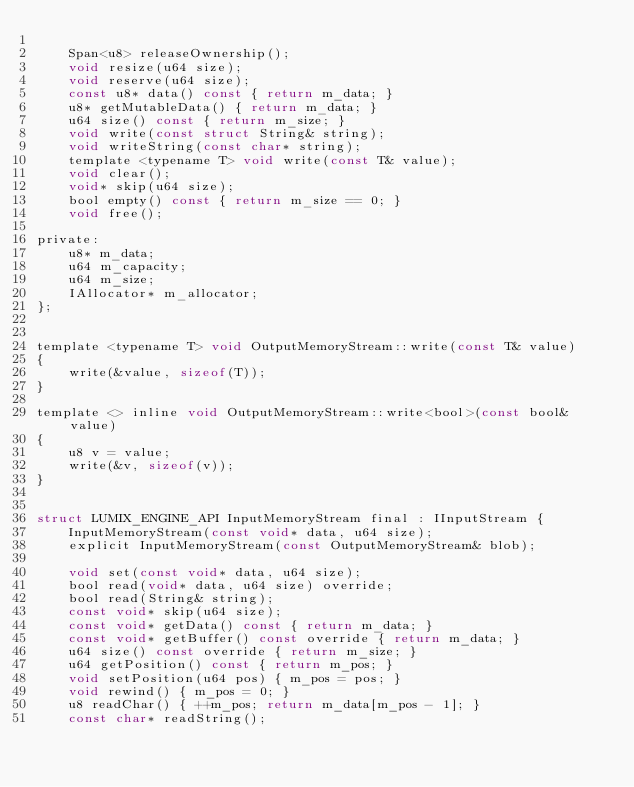Convert code to text. <code><loc_0><loc_0><loc_500><loc_500><_C_>
	Span<u8> releaseOwnership();
	void resize(u64 size);
	void reserve(u64 size);
	const u8* data() const { return m_data; }
	u8* getMutableData() { return m_data; }
	u64 size() const { return m_size; }
	void write(const struct String& string);
	void writeString(const char* string);
	template <typename T> void write(const T& value);
	void clear();
	void* skip(u64 size);
	bool empty() const { return m_size == 0; }
	void free();

private:
	u8* m_data;
	u64 m_capacity;
	u64 m_size;
	IAllocator* m_allocator;
};


template <typename T> void OutputMemoryStream::write(const T& value)
{
	write(&value, sizeof(T));
}

template <> inline void OutputMemoryStream::write<bool>(const bool& value)
{
	u8 v = value;
	write(&v, sizeof(v));
}


struct LUMIX_ENGINE_API InputMemoryStream final : IInputStream {
	InputMemoryStream(const void* data, u64 size);
	explicit InputMemoryStream(const OutputMemoryStream& blob);

	void set(const void* data, u64 size);
	bool read(void* data, u64 size) override;
	bool read(String& string);
	const void* skip(u64 size);
	const void* getData() const { return m_data; }
	const void* getBuffer() const override { return m_data; }
	u64 size() const override { return m_size; }
	u64 getPosition() const { return m_pos; }
	void setPosition(u64 pos) { m_pos = pos; }
	void rewind() { m_pos = 0; }
	u8 readChar() { ++m_pos; return m_data[m_pos - 1]; }
	const char* readString();
</code> 